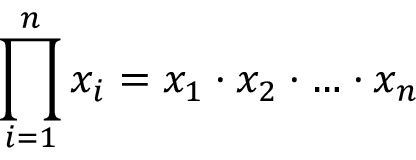<formula> <loc_0><loc_0><loc_500><loc_500>\prod _ { i = 1 } ^ { n } x _ { i } = x _ { 1 } \cdot x _ { 2 } \cdot \dots \cdot x _ { n }</formula> 